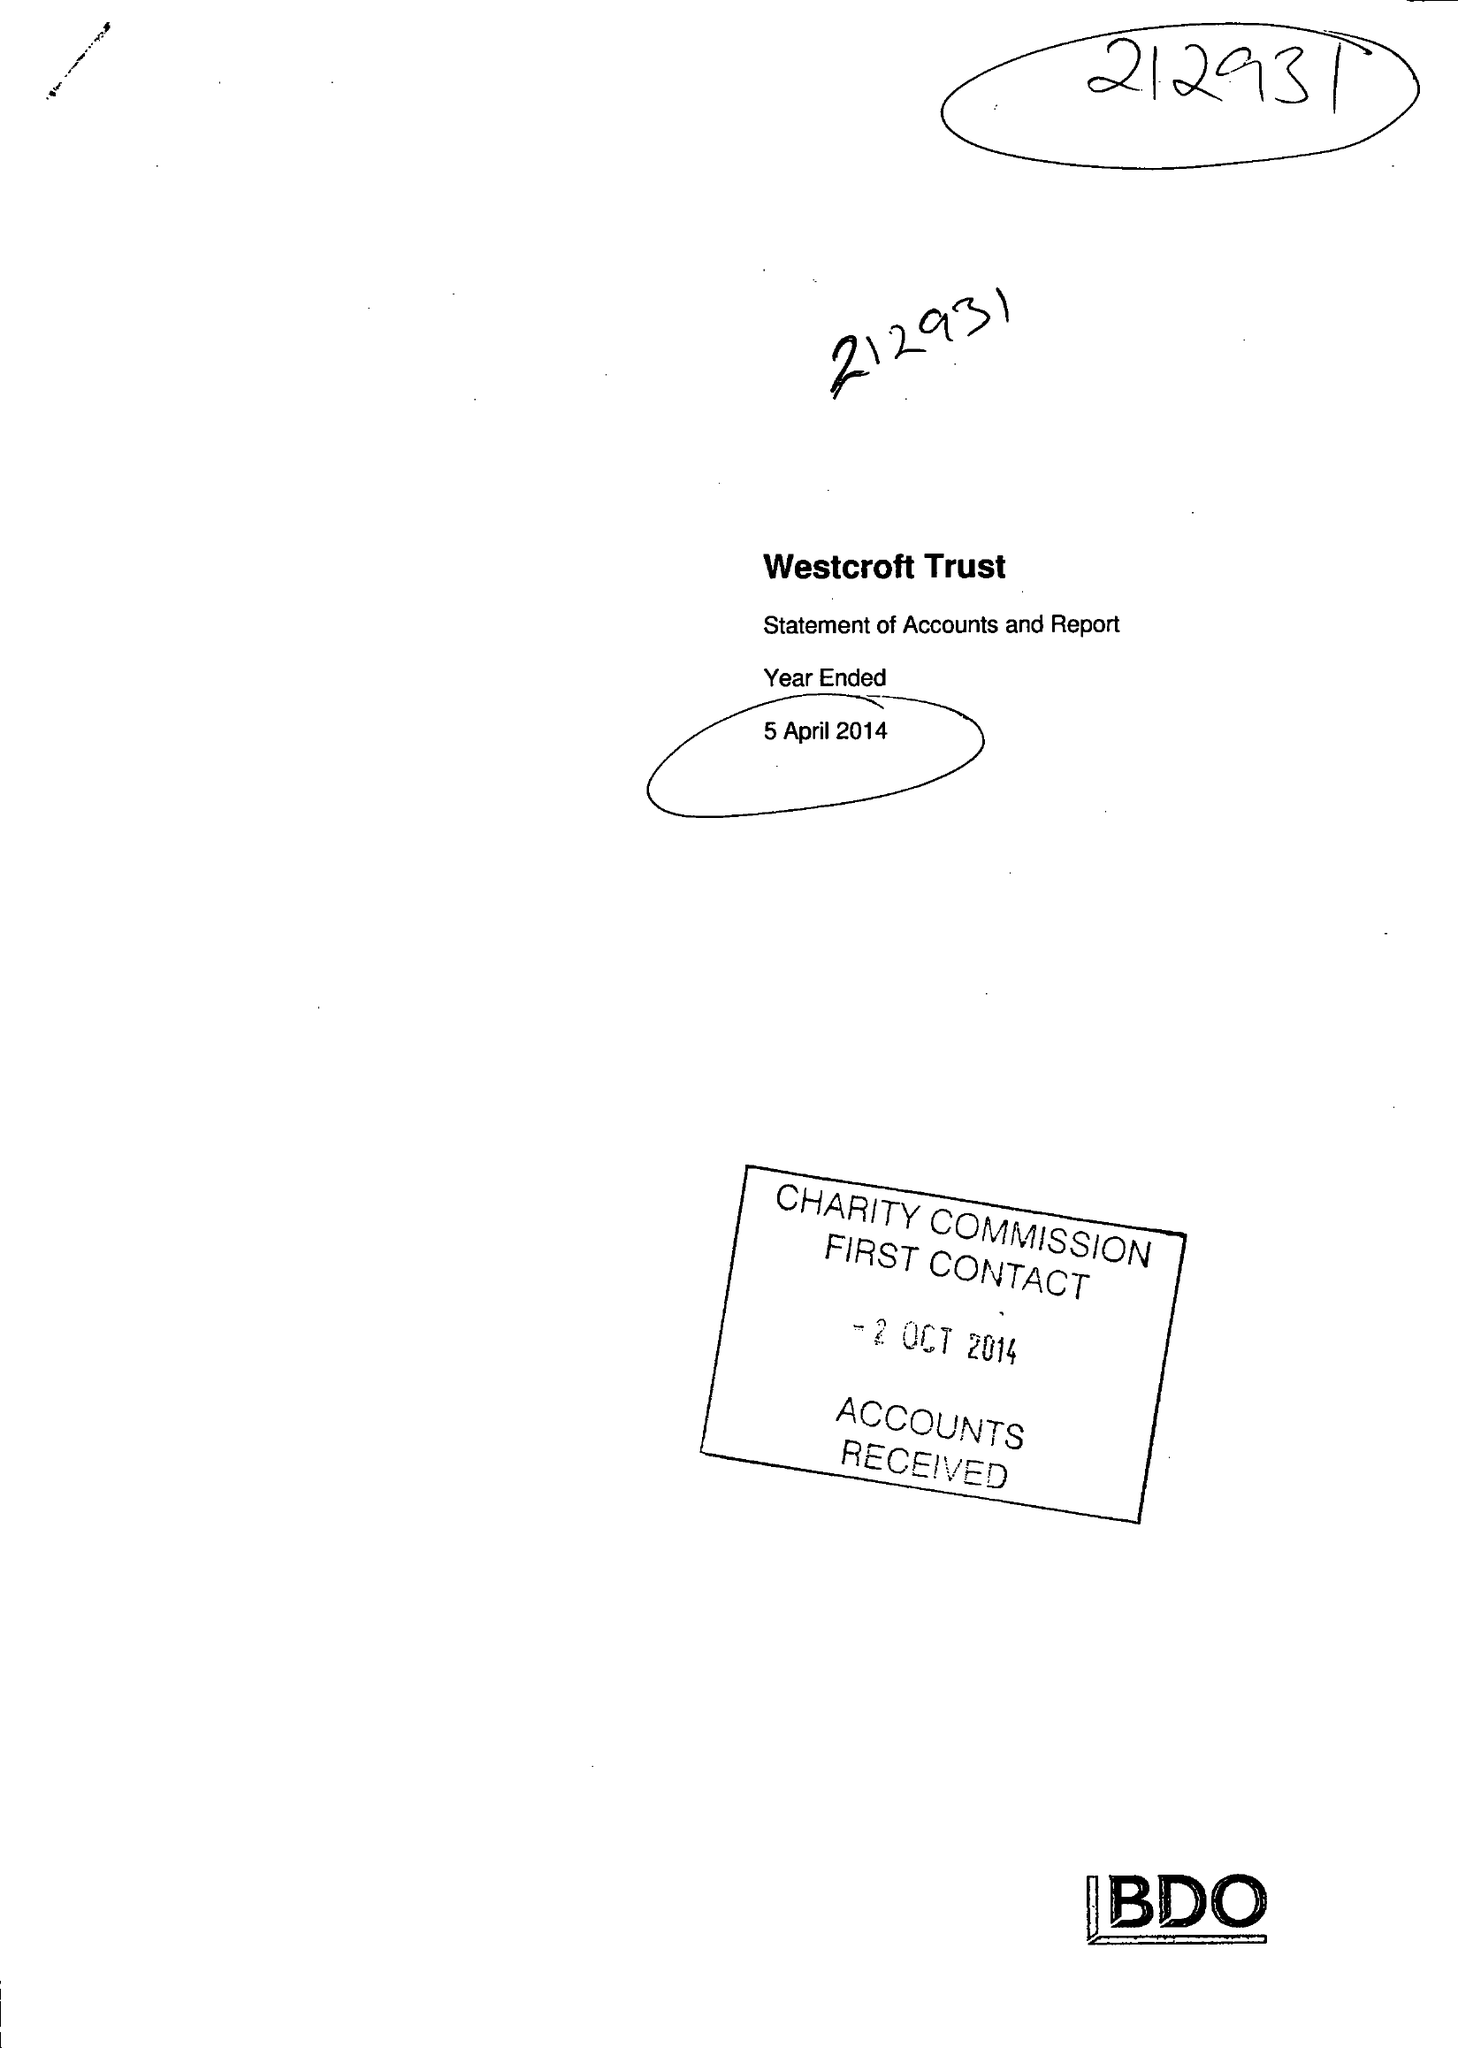What is the value for the spending_annually_in_british_pounds?
Answer the question using a single word or phrase. 113428.00 